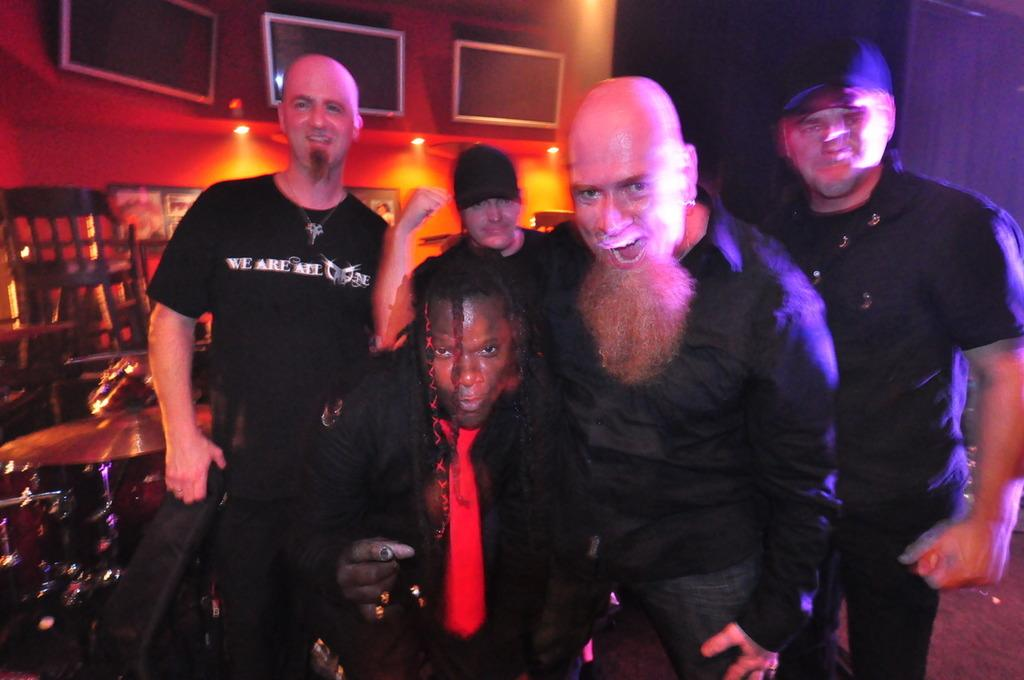What is the main focus of the image? There are people in the center of the image. What can be seen on the left side of the image? There is a band on the left side of the image. What is present on the wall in the background? There are screens placed on the wall in the background. What type of furniture is visible in the image? There are chairs visible in the image. What is used for illumination in the image? There are lights present in the image. Where is the faucet located in the image? There is no faucet present in the image. What type of writing instrument is being used by the band members in the image? The image does not show any writing instruments, such as quills, being used by the band members. 